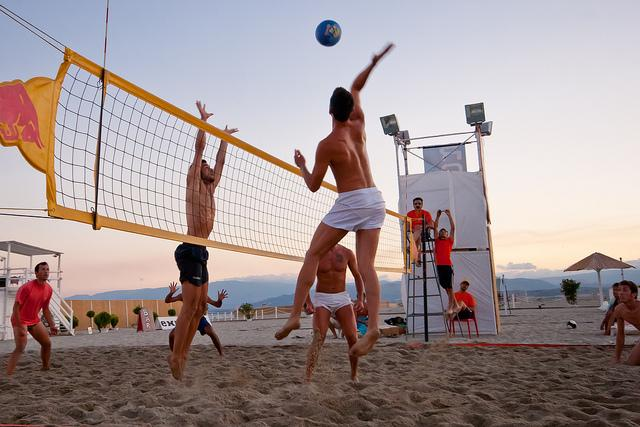What type volleyball is being played here? Please explain your reasoning. beach. Based on the amount of sand, it is safe to assume there is a body of water near by. 